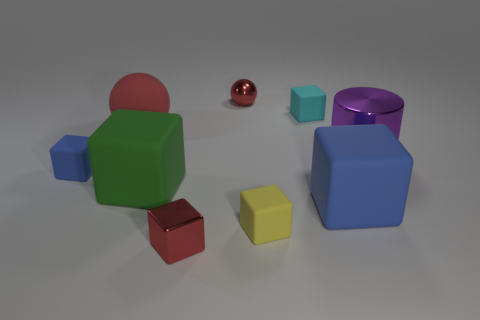Subtract all big blue matte cubes. How many cubes are left? 5 Subtract all cyan cylinders. How many blue blocks are left? 2 Subtract 4 cubes. How many cubes are left? 2 Subtract all red blocks. How many blocks are left? 5 Add 1 rubber spheres. How many objects exist? 10 Subtract all purple cubes. Subtract all green cylinders. How many cubes are left? 6 Add 5 green blocks. How many green blocks are left? 6 Add 1 large rubber things. How many large rubber things exist? 4 Subtract 0 yellow balls. How many objects are left? 9 Subtract all spheres. How many objects are left? 7 